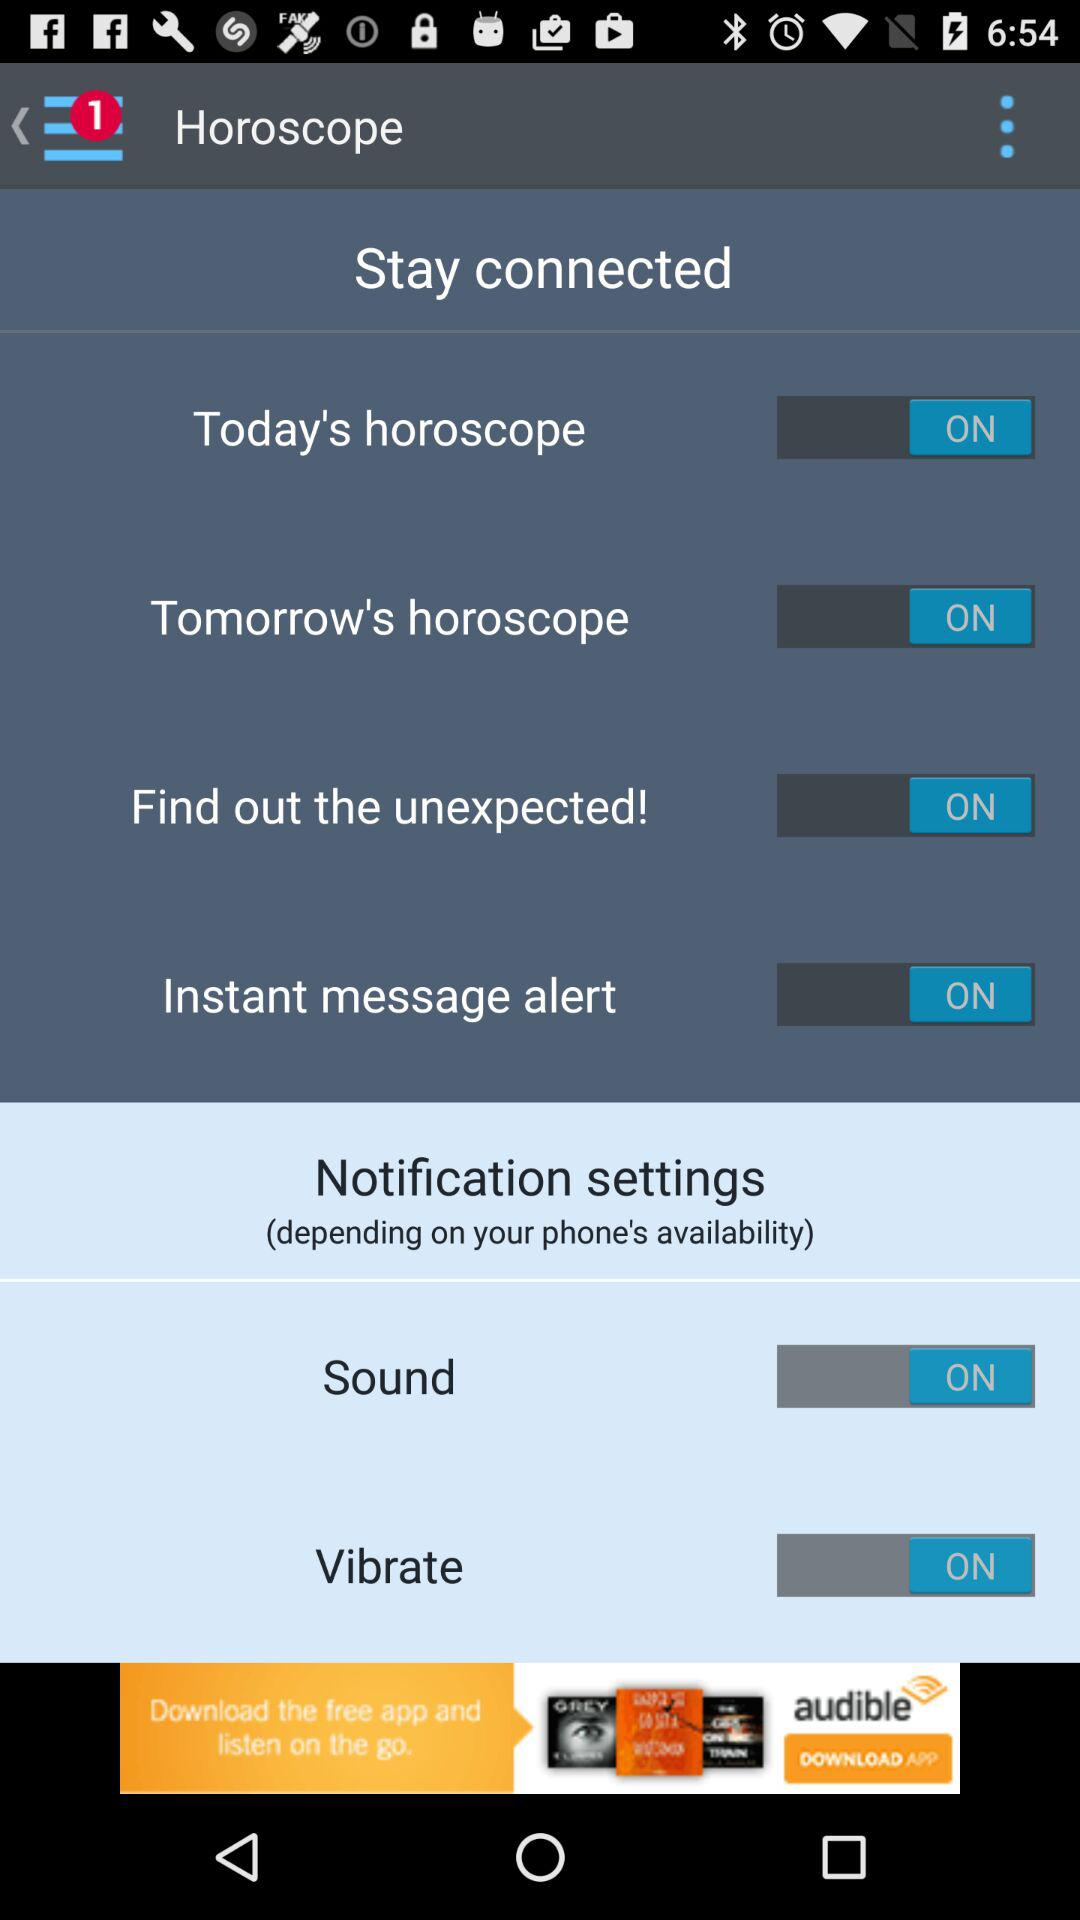What's the status of "Sound" in the notification settings? The status is "ON". 